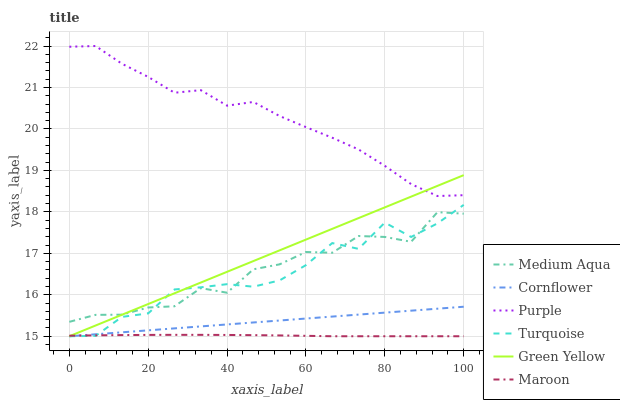Does Maroon have the minimum area under the curve?
Answer yes or no. Yes. Does Purple have the maximum area under the curve?
Answer yes or no. Yes. Does Turquoise have the minimum area under the curve?
Answer yes or no. No. Does Turquoise have the maximum area under the curve?
Answer yes or no. No. Is Cornflower the smoothest?
Answer yes or no. Yes. Is Turquoise the roughest?
Answer yes or no. Yes. Is Purple the smoothest?
Answer yes or no. No. Is Purple the roughest?
Answer yes or no. No. Does Cornflower have the lowest value?
Answer yes or no. Yes. Does Purple have the lowest value?
Answer yes or no. No. Does Purple have the highest value?
Answer yes or no. Yes. Does Turquoise have the highest value?
Answer yes or no. No. Is Maroon less than Purple?
Answer yes or no. Yes. Is Medium Aqua greater than Maroon?
Answer yes or no. Yes. Does Green Yellow intersect Medium Aqua?
Answer yes or no. Yes. Is Green Yellow less than Medium Aqua?
Answer yes or no. No. Is Green Yellow greater than Medium Aqua?
Answer yes or no. No. Does Maroon intersect Purple?
Answer yes or no. No. 